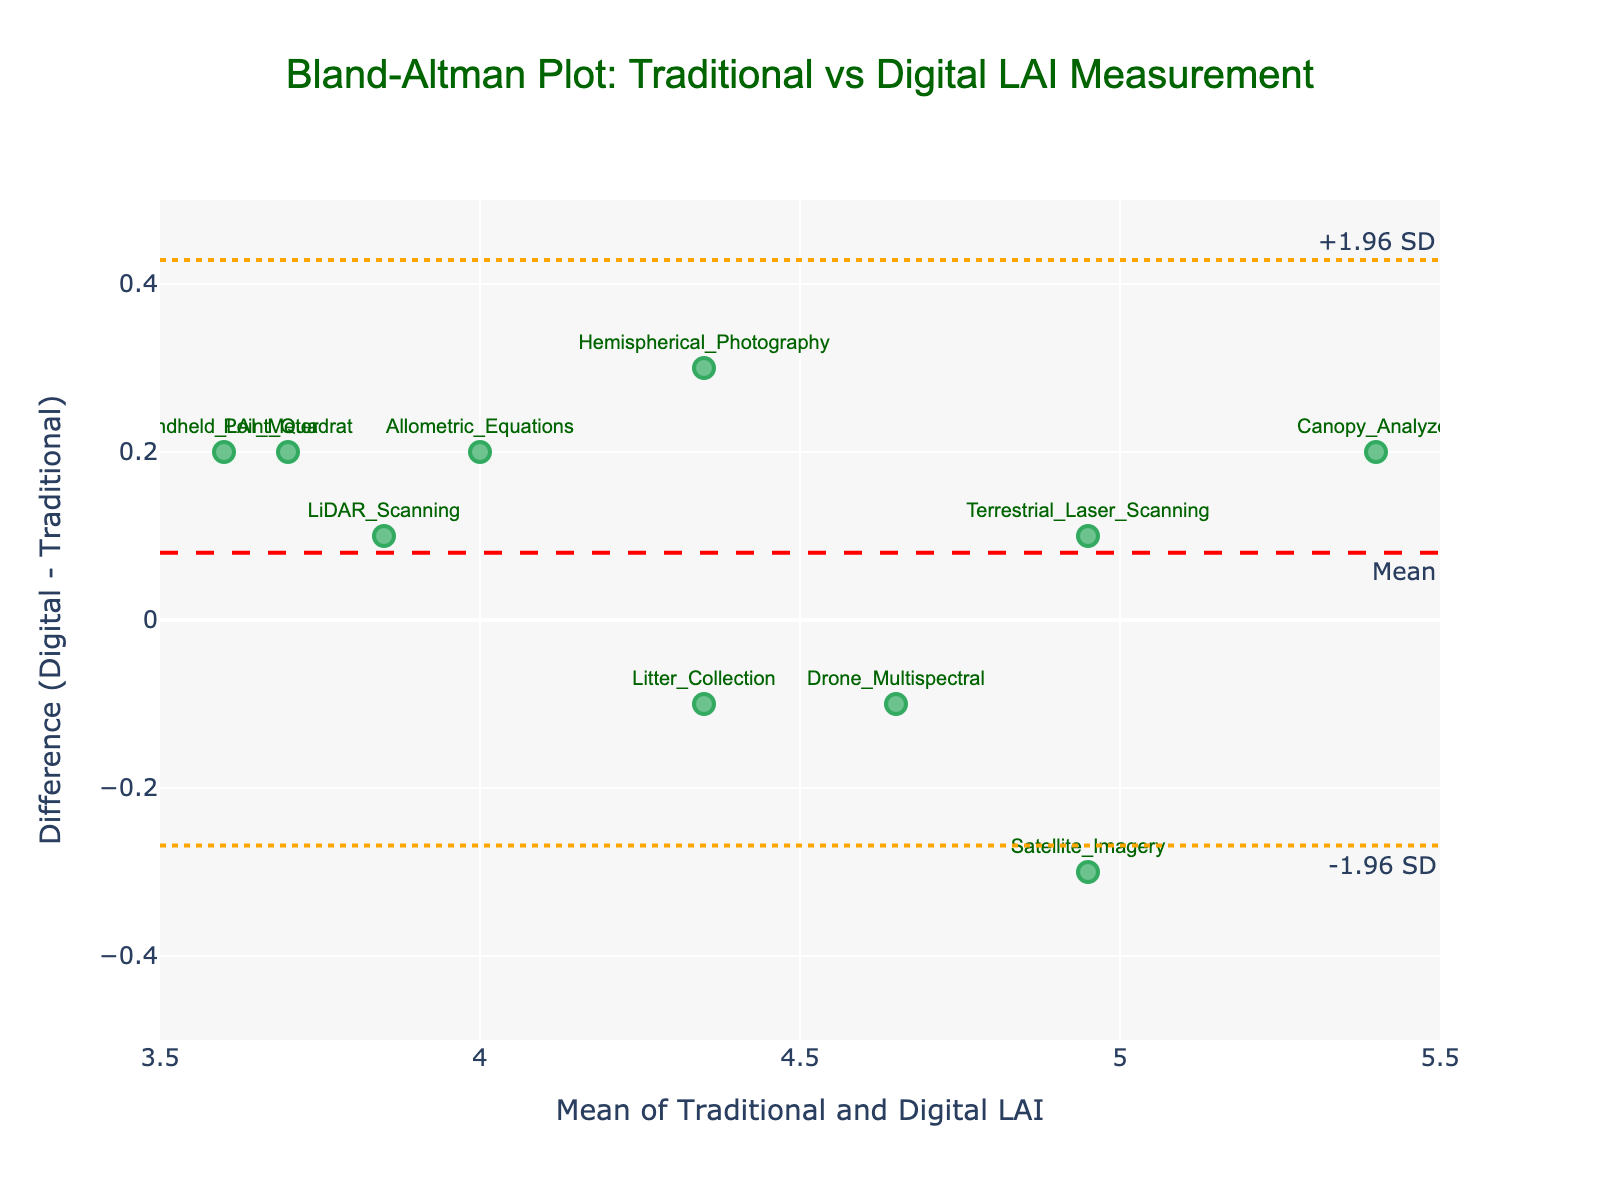what is the title of the plot? The title of the plot is located at the top center of the plot. It reads "Bland-Altman Plot: Traditional vs Digital LAI Measurement".
Answer: Bland-Altman Plot: Traditional vs Digital LAI Measurement How many data points are there in the figure? By looking at the scatter plot, you can count the number of markers representing the various methods. There are a total of 10 data points.
Answer: 10 Which measurement method has the highest mean LAI? Identify each point labeled with its respective method and compare the 'Mean' values. The 'Canopy_Analyzer' has the highest mean LAI of 5.4.
Answer: Canopy Analyzer What is the range of the 'Difference (Digital - Traditional)' axis? The y-axis range can be determined by observing the minimum and maximum tick marks. The range is from -0.5 to 0.5.
Answer: -0.5 to 0.5 What is the color of the mean line? The mean line is represented by a dashed line. By observing the color of this line, you can see that it is red.
Answer: Red What is the mean difference in the Bland-Altman plot? Mean difference is indicated by the red dashed horizontal line labeled "Mean". The value is the y-coordinate of this line.
Answer: Close to 0 What are the upper and lower limits of agreement? The upper and lower limits of agreement are depicted by the dotted lines in orange labeled "+1.96 SD" and "-1.96 SD" respectively. These lines are located above and below the mean difference line.
Answer: +1.96 SD and -1.96 SD Which method has the largest positive difference between digital and traditional LAI measurements? Examine the y-values (differences) for each data point and identify the method with the largest positive value. 'Hemispherical_Photography' has the largest positive difference of 0.3.
Answer: Hemispherical Photography Which method has the nearest zero difference between digital and traditional LAI measurements? Look for the data point whose difference value is closest to zero. 'LiDAR_Scanning' method has a difference of 0.1 which is closest to zero.
Answer: LiDAR Scanning Which methods show a negative difference between digital and traditional LAI measurements? Identify methods with negative y-values for 'Difference'. 'Satellite_Imagery', 'Drone_Multispectral', and 'Litter_Collection' have negative differences.
Answer: Satellite Imagery, Drone Multispectral, Litter Collection 